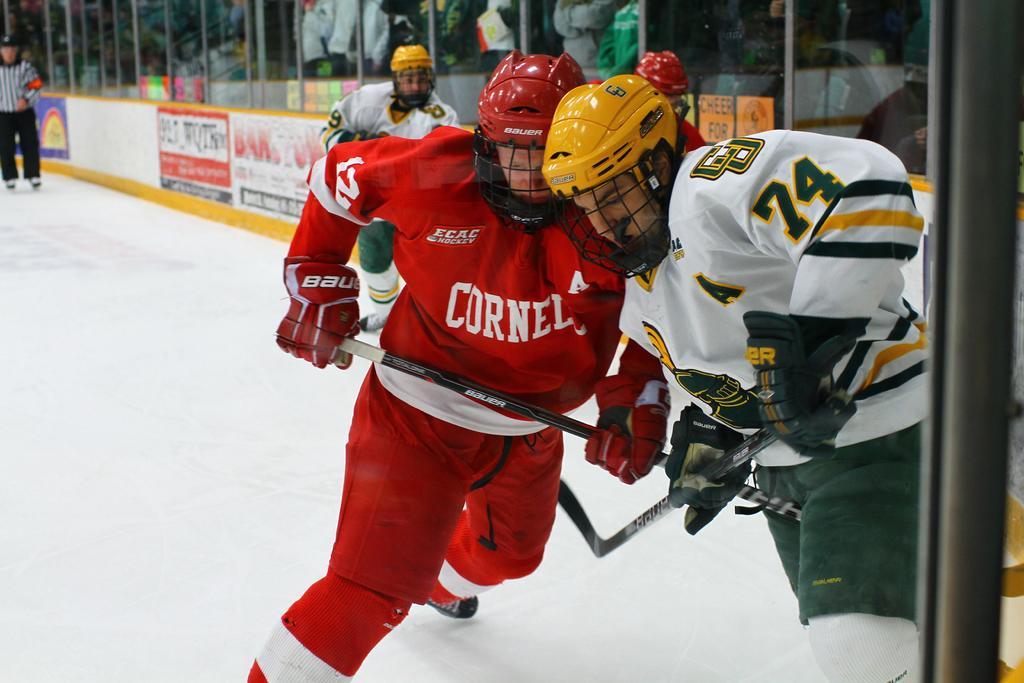Please provide a concise description of this image. In this picture there is a man who is wearing red, helmet, gloves, jacket and shoe. He is holding a stick. Here we can see another man who is wearing yellow helmet, white jacket, gloves and shoe. On the top left corner we can see umpire who is standing near to the board. On the top we can see audience was sitting on the chair and watching the game. 